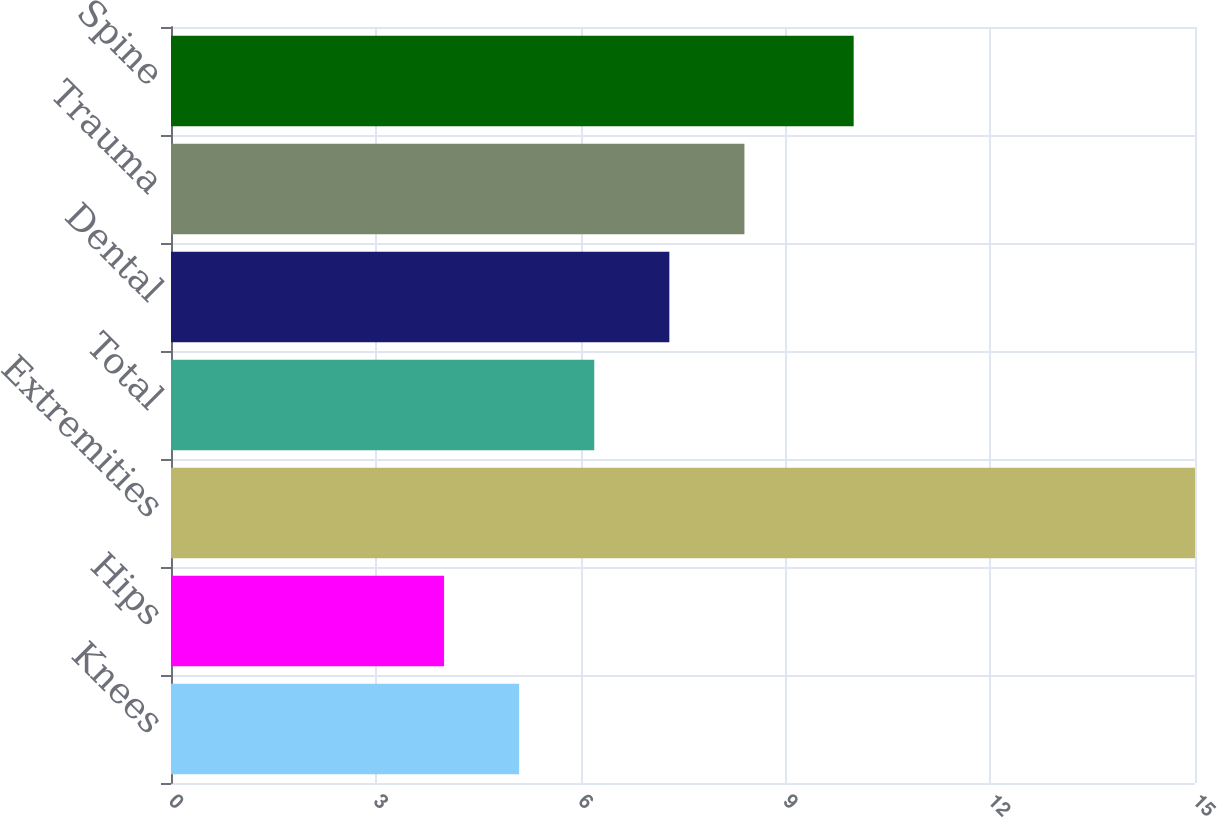Convert chart to OTSL. <chart><loc_0><loc_0><loc_500><loc_500><bar_chart><fcel>Knees<fcel>Hips<fcel>Extremities<fcel>Total<fcel>Dental<fcel>Trauma<fcel>Spine<nl><fcel>5.1<fcel>4<fcel>15<fcel>6.2<fcel>7.3<fcel>8.4<fcel>10<nl></chart> 